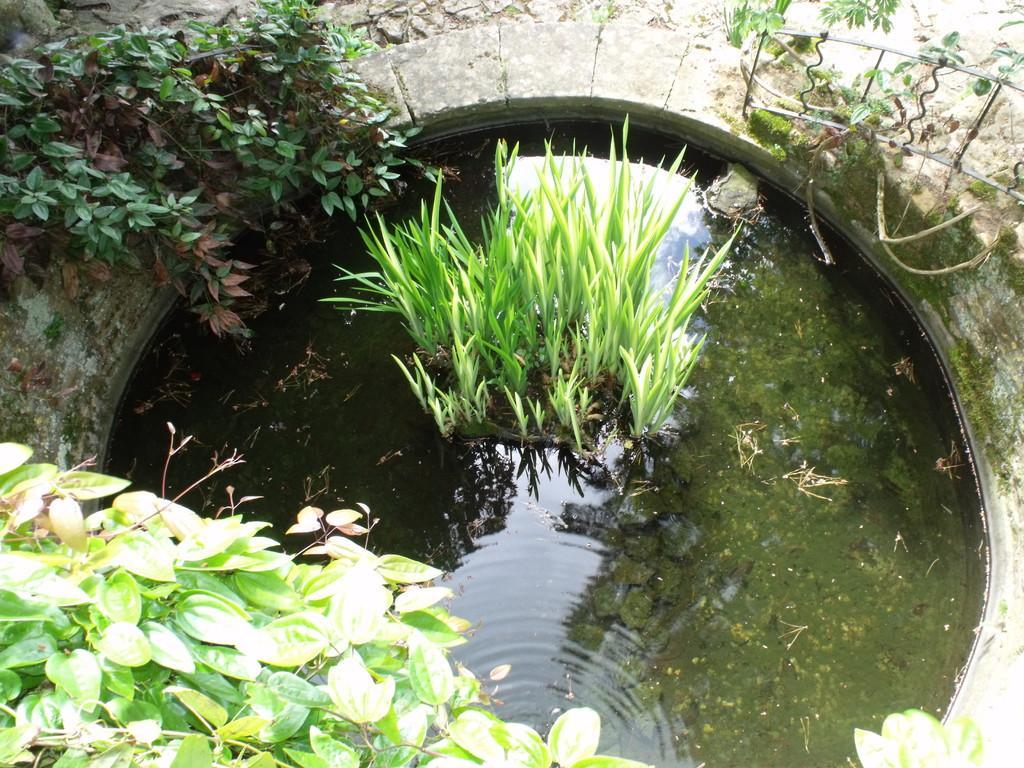How would you summarize this image in a sentence or two? In this picture we can see plants in water and in the background we can see trees. 